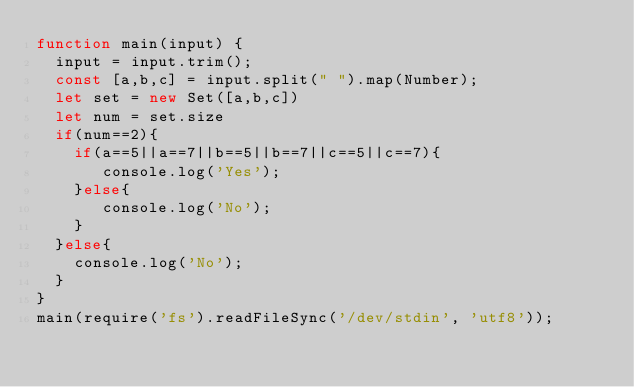<code> <loc_0><loc_0><loc_500><loc_500><_JavaScript_>function main(input) {
  input = input.trim();
  const [a,b,c] = input.split(" ").map(Number);
  let set = new Set([a,b,c])
  let num = set.size
  if(num==2){
    if(a==5||a==7||b==5||b==7||c==5||c==7){
       console.log('Yes');
    }else{
       console.log('No');
    }
  }else{
    console.log('No');
  }
}
main(require('fs').readFileSync('/dev/stdin', 'utf8'));
</code> 